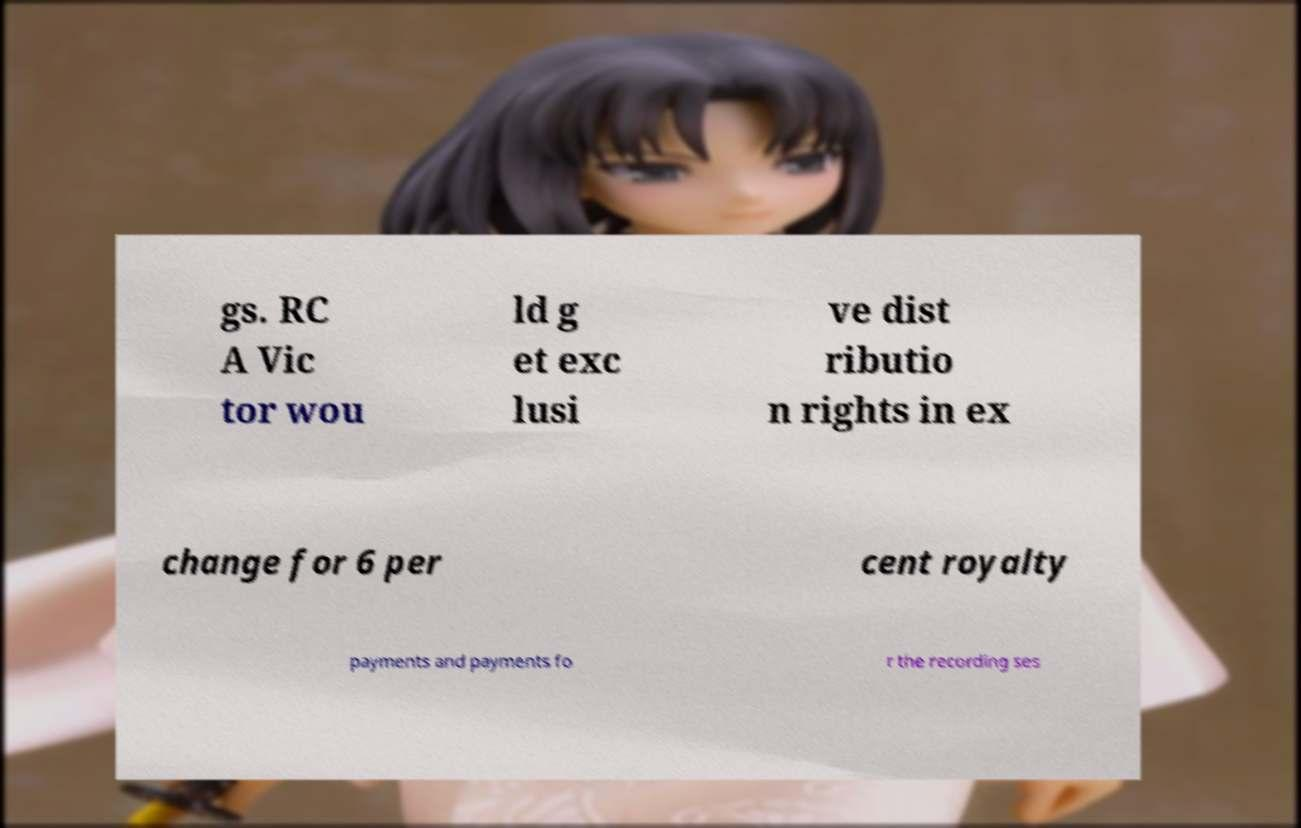Could you extract and type out the text from this image? gs. RC A Vic tor wou ld g et exc lusi ve dist ributio n rights in ex change for 6 per cent royalty payments and payments fo r the recording ses 